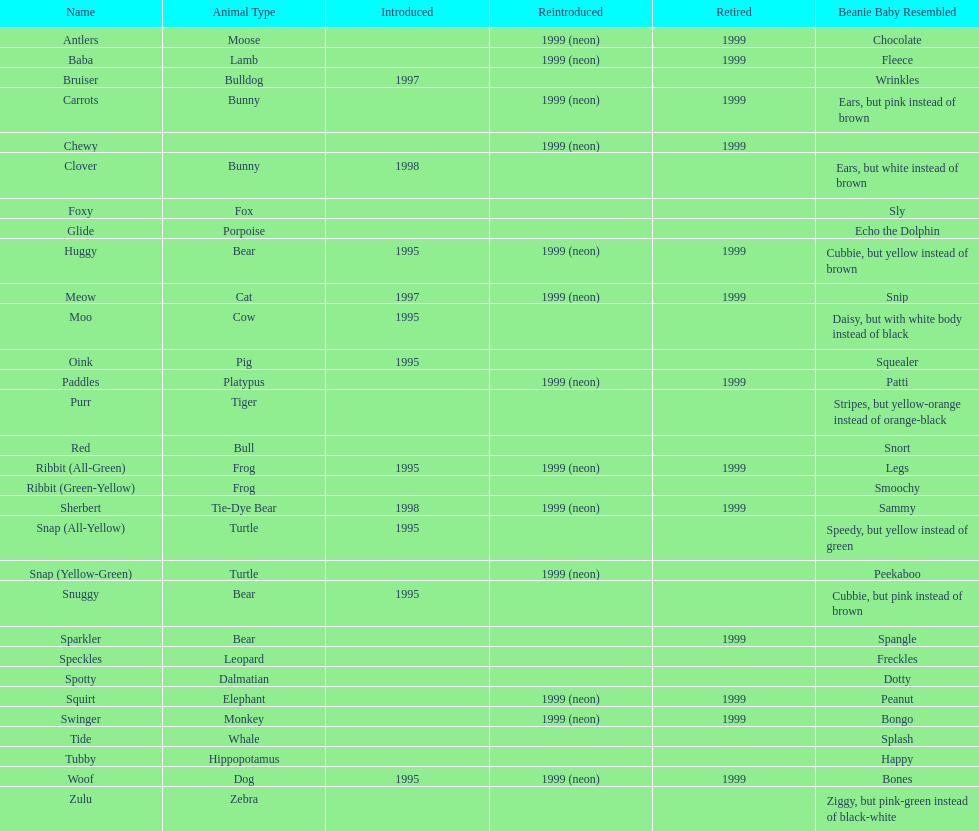What is the appellation of the pillow pal identified following clover? Foxy. 